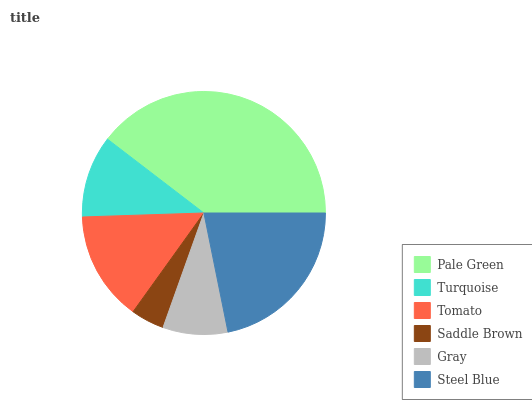Is Saddle Brown the minimum?
Answer yes or no. Yes. Is Pale Green the maximum?
Answer yes or no. Yes. Is Turquoise the minimum?
Answer yes or no. No. Is Turquoise the maximum?
Answer yes or no. No. Is Pale Green greater than Turquoise?
Answer yes or no. Yes. Is Turquoise less than Pale Green?
Answer yes or no. Yes. Is Turquoise greater than Pale Green?
Answer yes or no. No. Is Pale Green less than Turquoise?
Answer yes or no. No. Is Tomato the high median?
Answer yes or no. Yes. Is Turquoise the low median?
Answer yes or no. Yes. Is Pale Green the high median?
Answer yes or no. No. Is Steel Blue the low median?
Answer yes or no. No. 